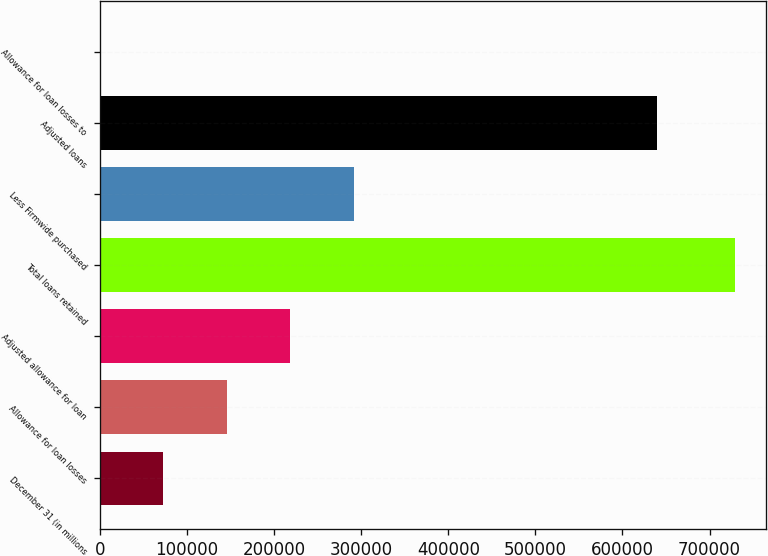Convert chart. <chart><loc_0><loc_0><loc_500><loc_500><bar_chart><fcel>December 31 (in millions<fcel>Allowance for loan losses<fcel>Adjusted allowance for loan<fcel>Total loans retained<fcel>Less Firmwide purchased<fcel>Adjusted loans<fcel>Allowance for loan losses to<nl><fcel>72894.8<fcel>145786<fcel>218677<fcel>728915<fcel>291568<fcel>639827<fcel>3.62<nl></chart> 